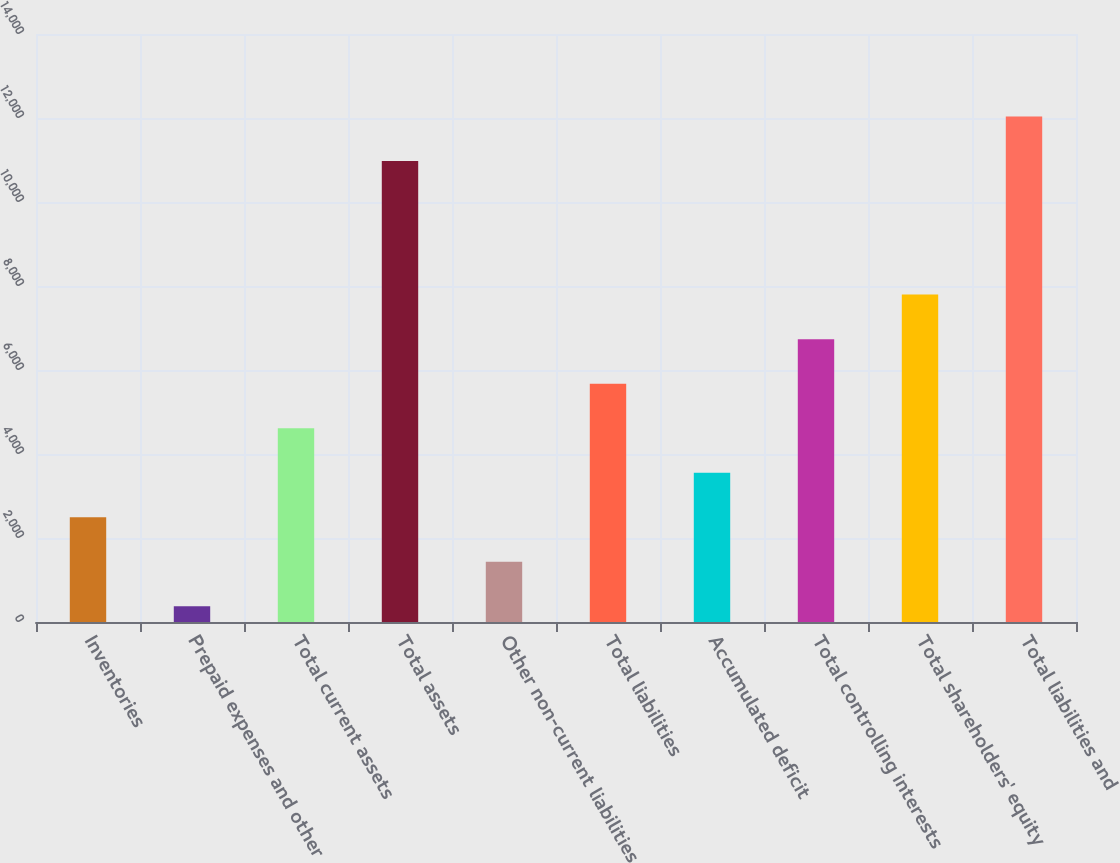Convert chart. <chart><loc_0><loc_0><loc_500><loc_500><bar_chart><fcel>Inventories<fcel>Prepaid expenses and other<fcel>Total current assets<fcel>Total assets<fcel>Other non-current liabilities<fcel>Total liabilities<fcel>Accumulated deficit<fcel>Total controlling interests<fcel>Total shareholders' equity<fcel>Total liabilities and<nl><fcel>2494.62<fcel>374.5<fcel>4614.74<fcel>10975.1<fcel>1434.56<fcel>5674.8<fcel>3554.68<fcel>6734.86<fcel>7794.92<fcel>12035.2<nl></chart> 